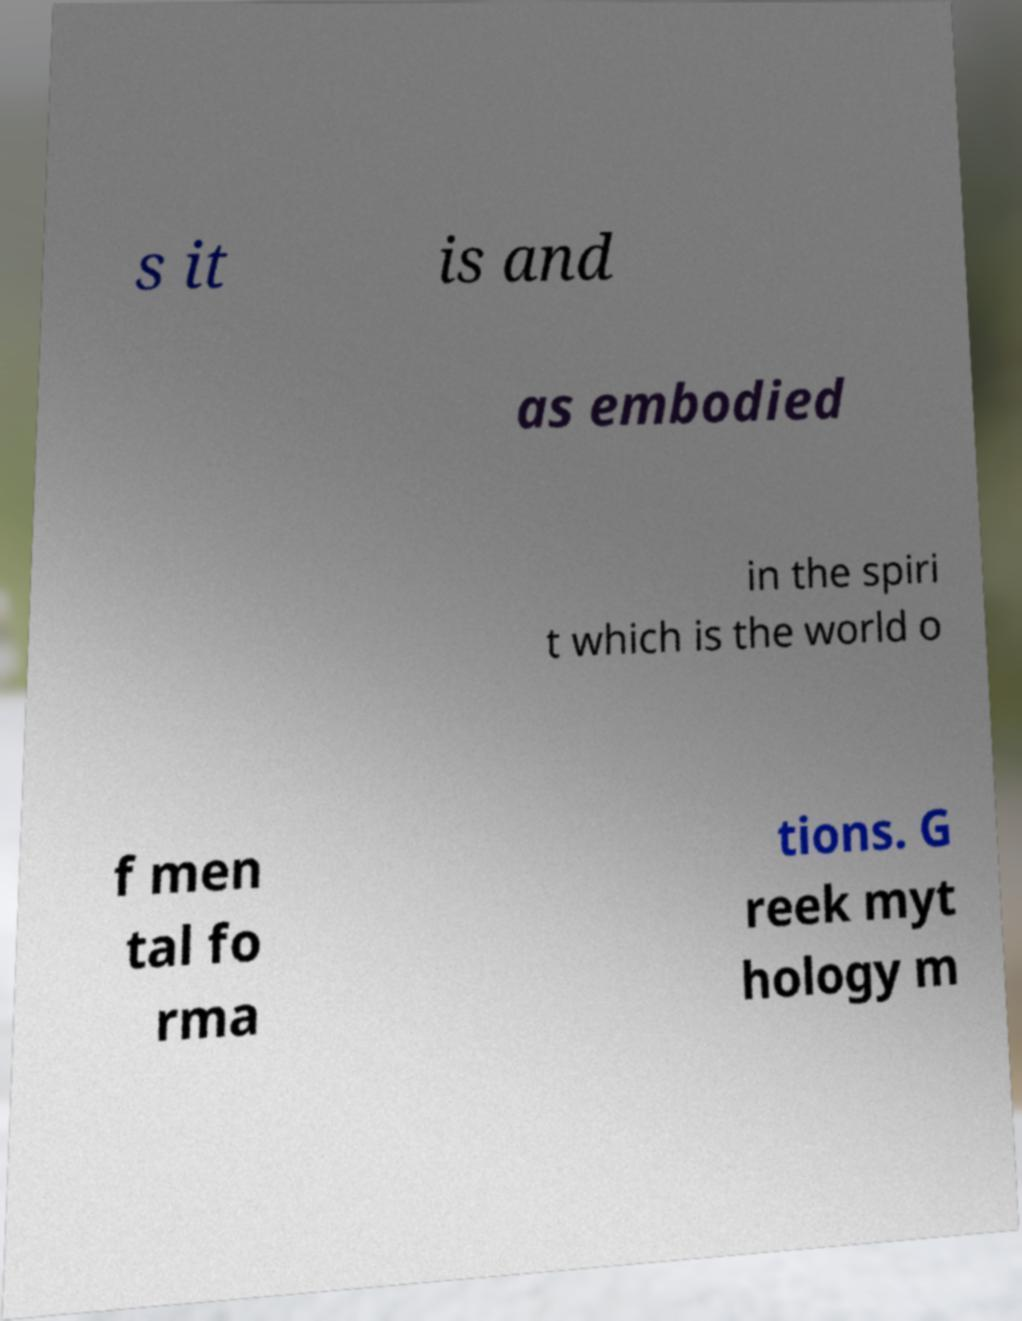Could you extract and type out the text from this image? s it is and as embodied in the spiri t which is the world o f men tal fo rma tions. G reek myt hology m 